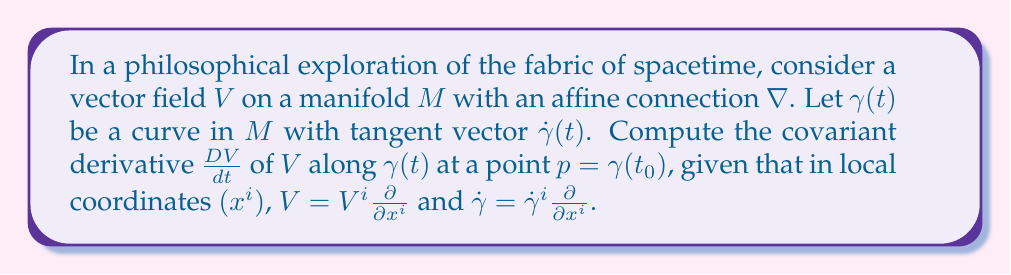Show me your answer to this math problem. Let's approach this step-by-step:

1) The covariant derivative of a vector field $V$ along a curve $\gamma(t)$ is defined as:

   $$\frac{D V}{dt} = \nabla_{\dot{\gamma}} V$$

2) In local coordinates, we can express this as:

   $$\frac{D V}{dt} = \left(\frac{dV^i}{dt} + \Gamma^i_{jk} V^j \dot{\gamma}^k\right) \frac{\partial}{\partial x^i}$$

   where $\Gamma^i_{jk}$ are the Christoffel symbols of the connection.

3) Let's break down each term:

   a) $\frac{dV^i}{dt}$ represents the rate of change of the components of $V$ along the curve.
   
   b) $\Gamma^i_{jk} V^j \dot{\gamma}^k$ accounts for the change in the basis vectors as we move along the curve.

4) To compute this at the point $p = \gamma(t_0)$, we evaluate all terms at $t = t_0$:

   $$\left.\frac{D V}{dt}\right|_{p} = \left.\left(\frac{dV^i}{dt} + \Gamma^i_{jk} V^j \dot{\gamma}^k\right)\right|_{t=t_0} \frac{\partial}{\partial x^i}$$

5) This expression gives us the covariant derivative of $V$ along $\gamma$ at the point $p$ in terms of the local coordinates, the components of $V$ and $\dot{\gamma}$, and the Christoffel symbols of the connection.
Answer: $$\left.\frac{D V}{dt}\right|_{p} = \left.\left(\frac{dV^i}{dt} + \Gamma^i_{jk} V^j \dot{\gamma}^k\right)\right|_{t=t_0} \frac{\partial}{\partial x^i}$$ 